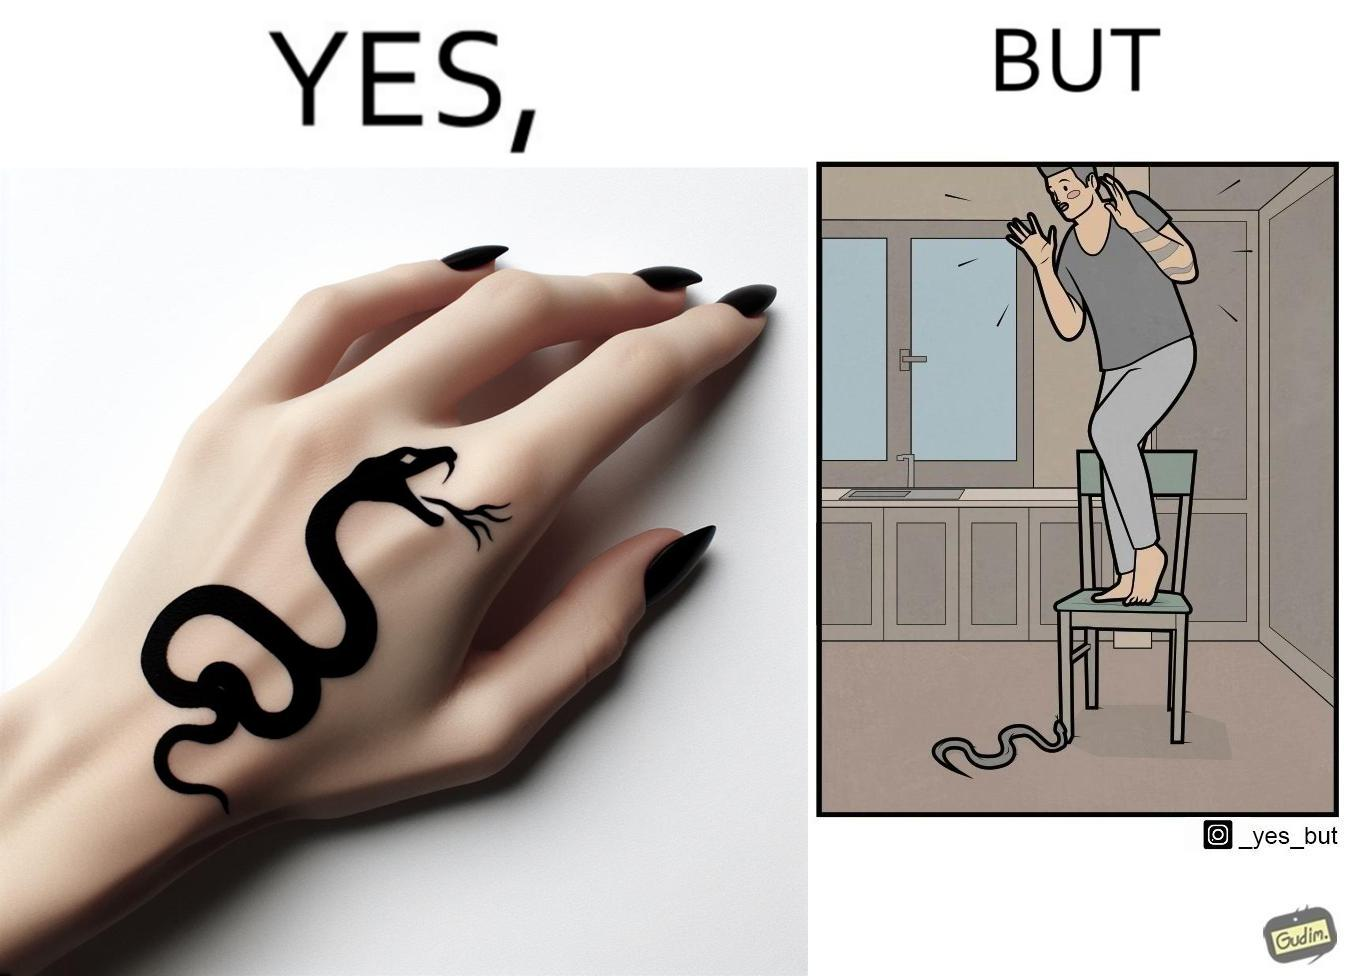What is the satirical meaning behind this image? The image is ironic, because in the first image the tattoo of a snake on someone's hand may give us a hint about how powerful or brave the person can be who is having this tattoo but in the second image the person with same tattoo is seen frightened due to a snake in his house 